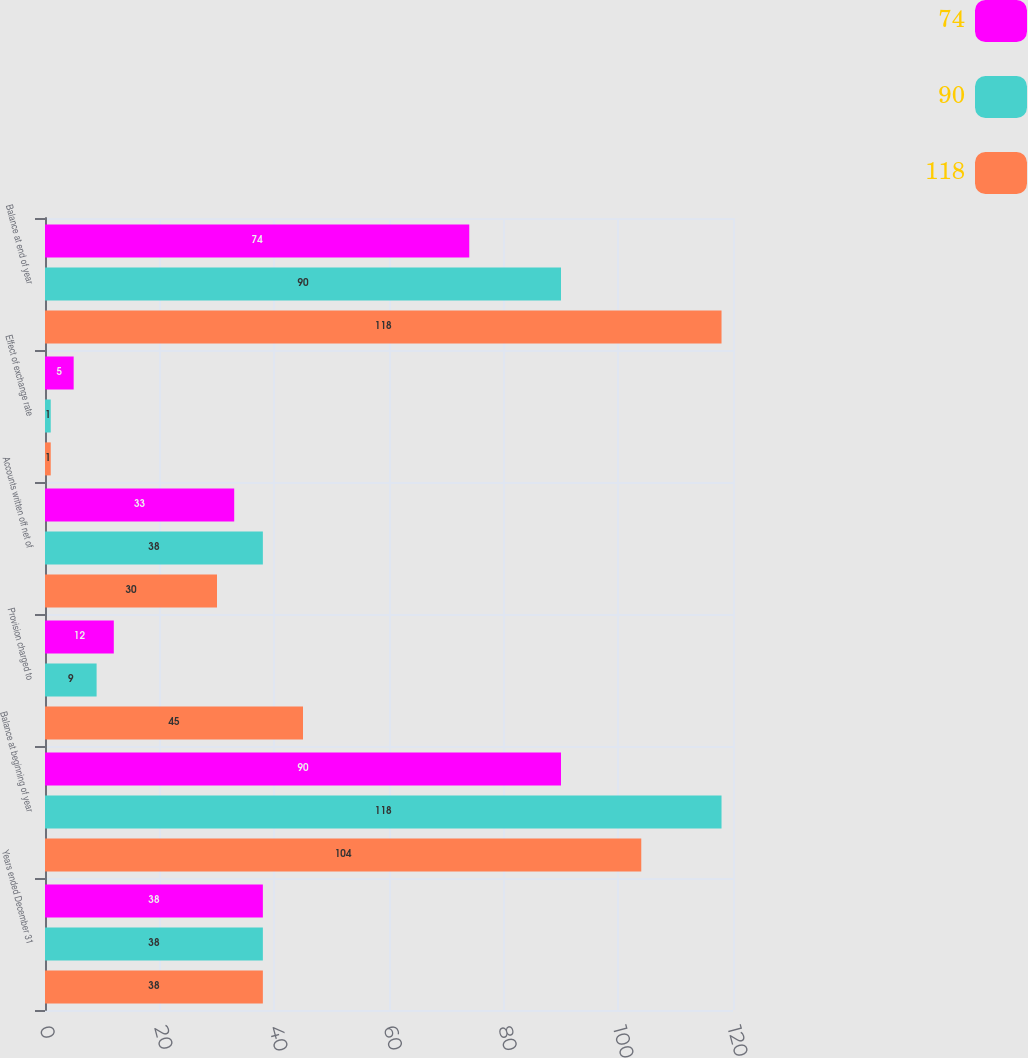Convert chart to OTSL. <chart><loc_0><loc_0><loc_500><loc_500><stacked_bar_chart><ecel><fcel>Years ended December 31<fcel>Balance at beginning of year<fcel>Provision charged to<fcel>Accounts written off net of<fcel>Effect of exchange rate<fcel>Balance at end of year<nl><fcel>74<fcel>38<fcel>90<fcel>12<fcel>33<fcel>5<fcel>74<nl><fcel>90<fcel>38<fcel>118<fcel>9<fcel>38<fcel>1<fcel>90<nl><fcel>118<fcel>38<fcel>104<fcel>45<fcel>30<fcel>1<fcel>118<nl></chart> 